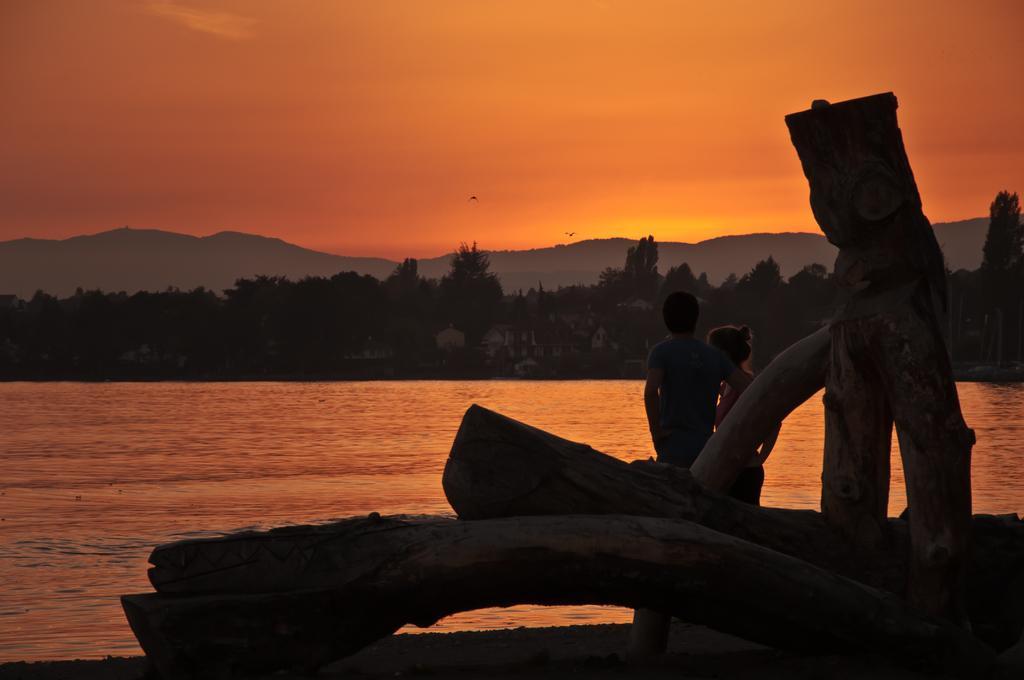Please provide a concise description of this image. In the center of the image we can see tree trunks and two persons are standing. In the background, we can see the sky, trees, buildings, hills, water and two birds are flying. 